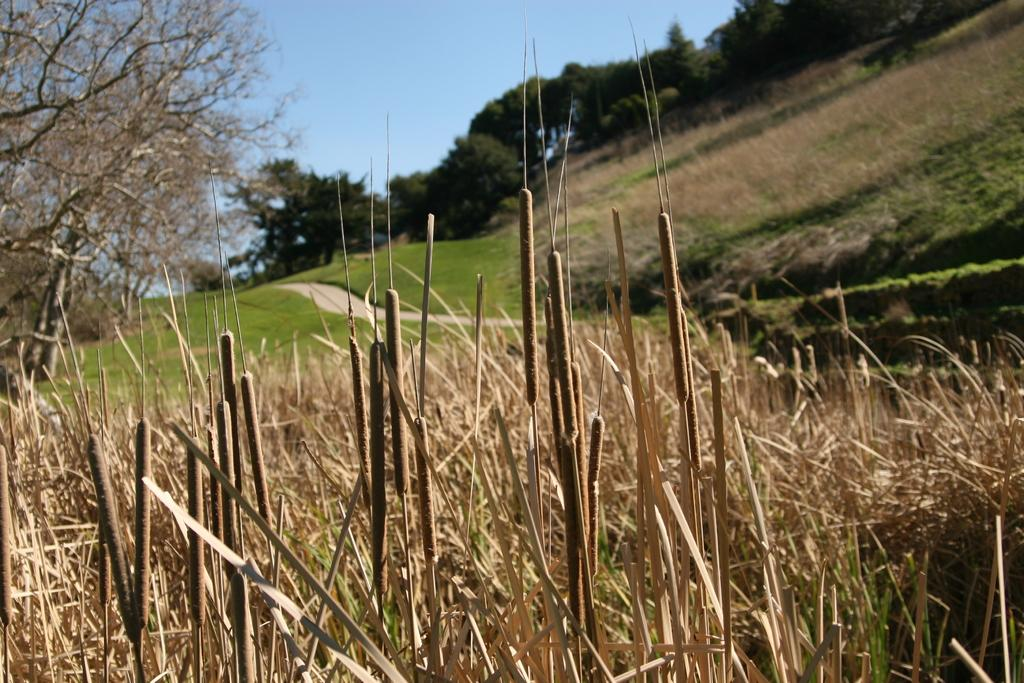What type of vegetation can be seen in the image? There are many plants with dry leaves in the image. What can be seen in the background of the image? There are trees and the sky visible in the background of the image. What is on the ground in the image? There is grass on the ground in the image. What else is visible in the image besides the plants and trees? There is a road visible in the image. What color is the sock on the tree in the image? There is no sock present in the image; it only features plants, trees, a road, grass, and the sky. 